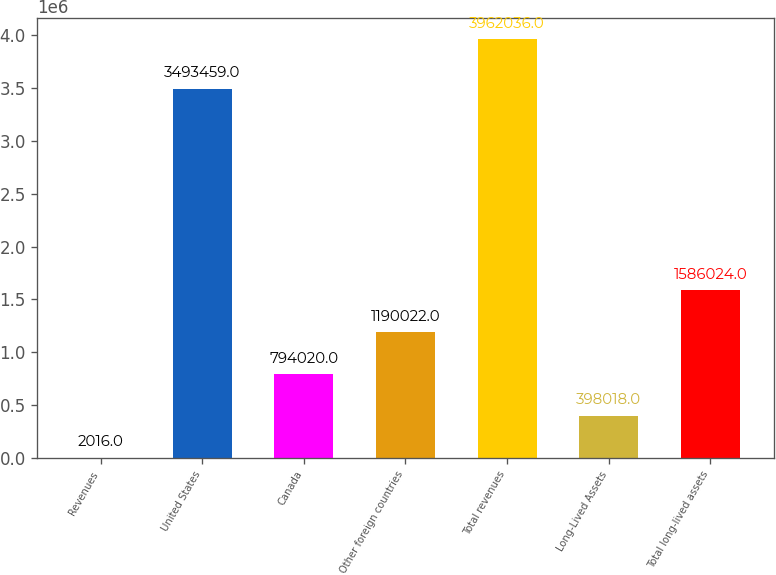Convert chart. <chart><loc_0><loc_0><loc_500><loc_500><bar_chart><fcel>Revenues<fcel>United States<fcel>Canada<fcel>Other foreign countries<fcel>Total revenues<fcel>Long-Lived Assets<fcel>Total long-lived assets<nl><fcel>2016<fcel>3.49346e+06<fcel>794020<fcel>1.19002e+06<fcel>3.96204e+06<fcel>398018<fcel>1.58602e+06<nl></chart> 